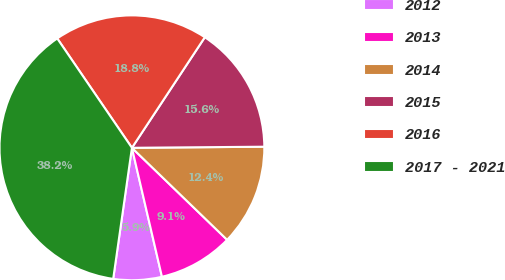Convert chart. <chart><loc_0><loc_0><loc_500><loc_500><pie_chart><fcel>2012<fcel>2013<fcel>2014<fcel>2015<fcel>2016<fcel>2017 - 2021<nl><fcel>5.9%<fcel>9.13%<fcel>12.36%<fcel>15.59%<fcel>18.82%<fcel>38.21%<nl></chart> 